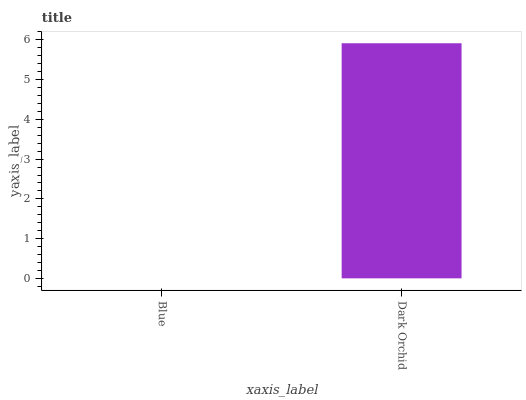Is Blue the minimum?
Answer yes or no. Yes. Is Dark Orchid the maximum?
Answer yes or no. Yes. Is Dark Orchid the minimum?
Answer yes or no. No. Is Dark Orchid greater than Blue?
Answer yes or no. Yes. Is Blue less than Dark Orchid?
Answer yes or no. Yes. Is Blue greater than Dark Orchid?
Answer yes or no. No. Is Dark Orchid less than Blue?
Answer yes or no. No. Is Dark Orchid the high median?
Answer yes or no. Yes. Is Blue the low median?
Answer yes or no. Yes. Is Blue the high median?
Answer yes or no. No. Is Dark Orchid the low median?
Answer yes or no. No. 